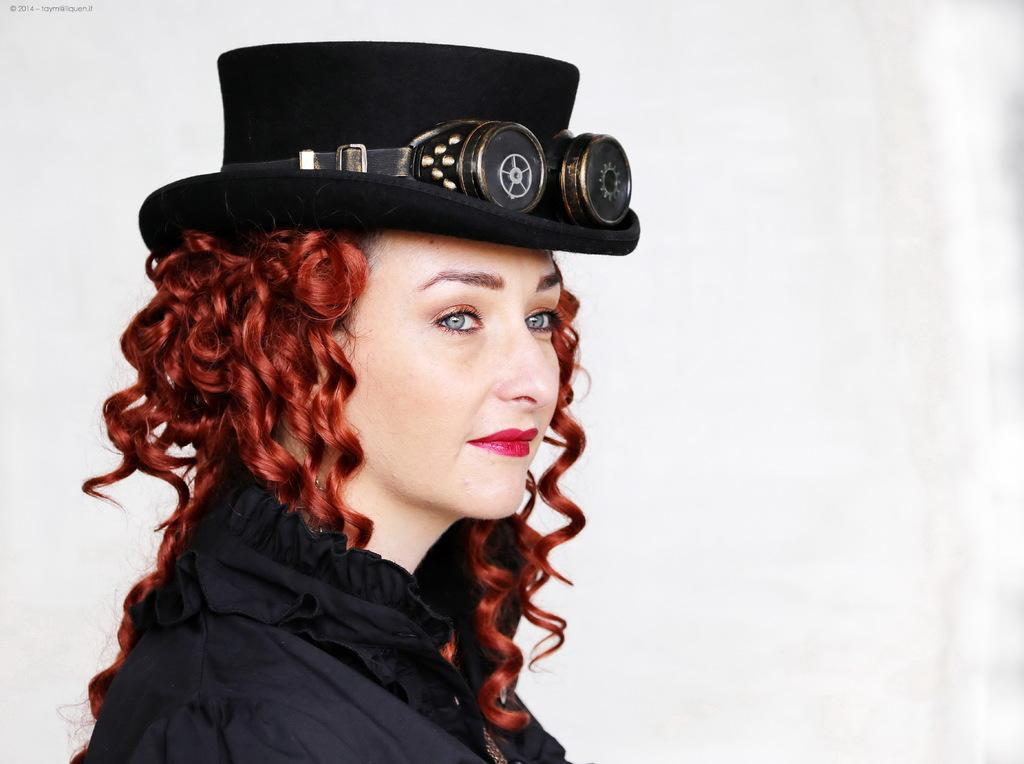Who is the main subject in the foreground of the image? There is a woman in the foreground of the image. What is the woman wearing on her head? The woman is wearing a hat. What can be seen in the background of the image? There is a wall in the background of the image. What type of rice is being cooked in the image? There is no rice present in the image; it features a woman wearing a hat in the foreground and a wall in the background. 